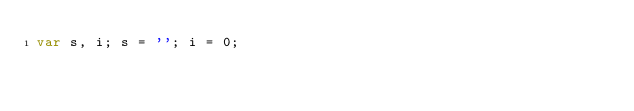<code> <loc_0><loc_0><loc_500><loc_500><_JavaScript_>var s, i; s = ''; i = 0;</code> 